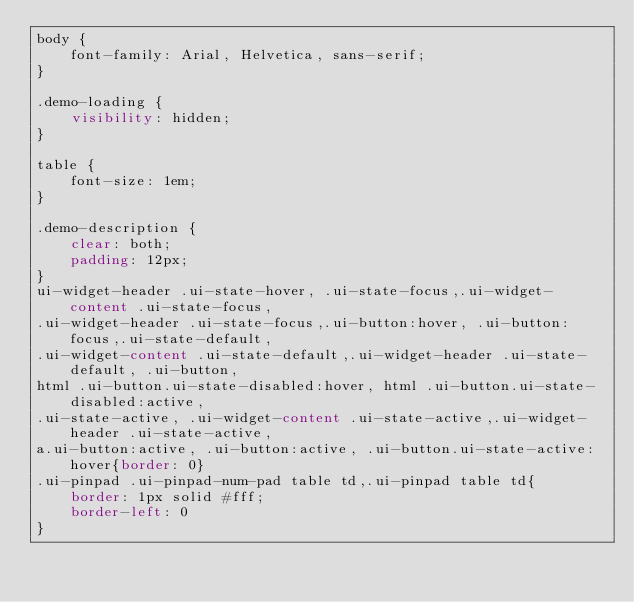<code> <loc_0><loc_0><loc_500><loc_500><_CSS_>body {
    font-family: Arial, Helvetica, sans-serif;
}

.demo-loading {
    visibility: hidden;
}

table {
    font-size: 1em;
}

.demo-description {
    clear: both;
    padding: 12px;
}
ui-widget-header .ui-state-hover, .ui-state-focus,.ui-widget-content .ui-state-focus,
.ui-widget-header .ui-state-focus,.ui-button:hover, .ui-button:focus,.ui-state-default,
.ui-widget-content .ui-state-default,.ui-widget-header .ui-state-default, .ui-button,
html .ui-button.ui-state-disabled:hover, html .ui-button.ui-state-disabled:active,
.ui-state-active, .ui-widget-content .ui-state-active,.ui-widget-header .ui-state-active,
a.ui-button:active, .ui-button:active, .ui-button.ui-state-active:hover{border: 0}
.ui-pinpad .ui-pinpad-num-pad table td,.ui-pinpad table td{
    border: 1px solid #fff;
    border-left: 0
}</code> 